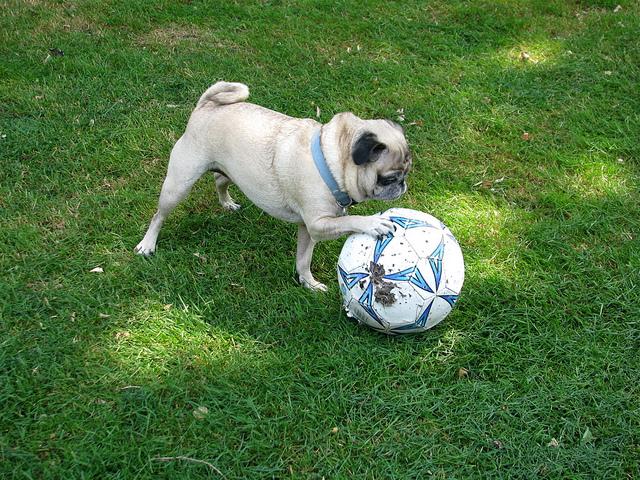What kind of dog is this?
Concise answer only. Pug. What type of ground cover is in this photo?
Write a very short answer. Grass. What type of dog is this?
Be succinct. Pug. What is this dog playing with?
Quick response, please. Ball. Is the ball dirty?
Concise answer only. Yes. What color is the dog?
Give a very brief answer. Tan. 